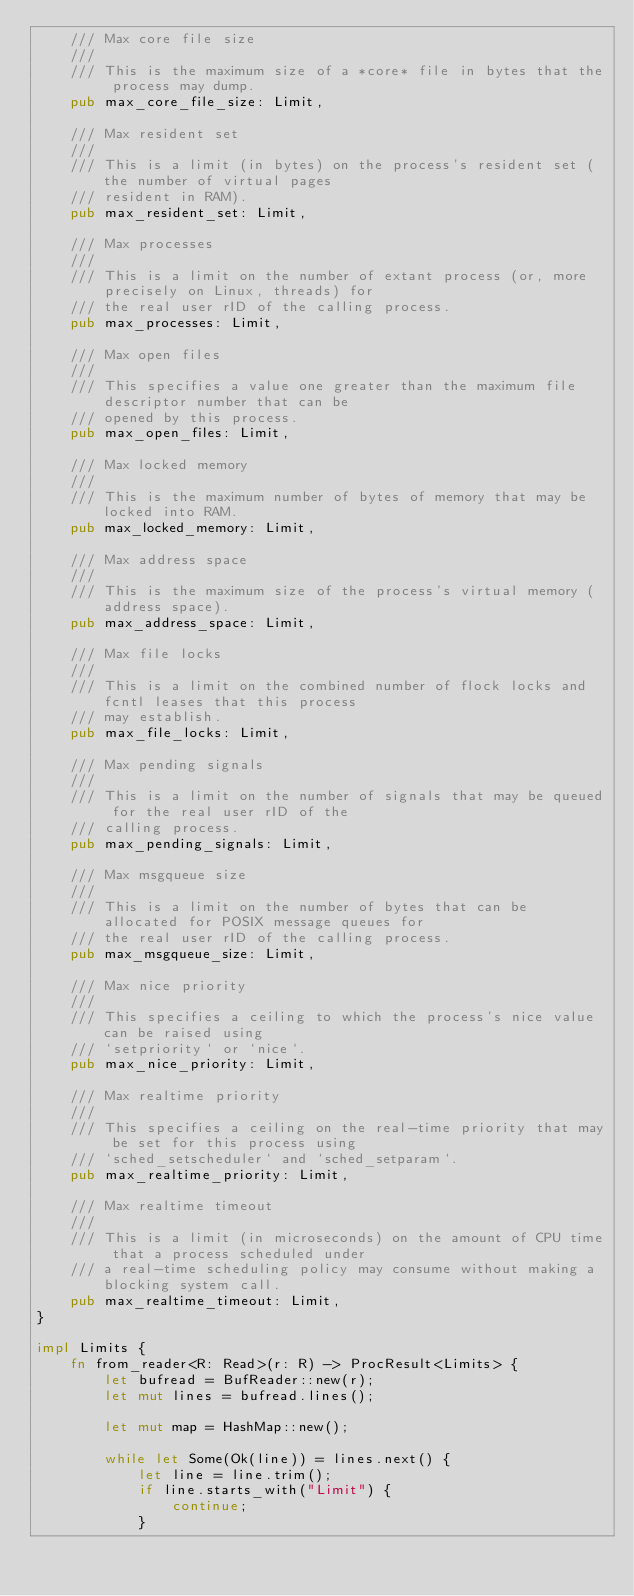Convert code to text. <code><loc_0><loc_0><loc_500><loc_500><_Rust_>    /// Max core file size
    ///
    /// This is the maximum size of a *core* file in bytes that the process may dump.
    pub max_core_file_size: Limit,

    /// Max resident set
    ///
    /// This is a limit (in bytes) on the process's resident set (the number of virtual pages
    /// resident in RAM).
    pub max_resident_set: Limit,

    /// Max processes
    ///
    /// This is a limit on the number of extant process (or, more precisely on Linux, threads) for
    /// the real user rID of the calling process.
    pub max_processes: Limit,

    /// Max open files
    ///
    /// This specifies a value one greater than the maximum file descriptor number that can be
    /// opened by this process.
    pub max_open_files: Limit,

    /// Max locked memory
    ///
    /// This is the maximum number of bytes of memory that may be locked into RAM.
    pub max_locked_memory: Limit,

    /// Max address space
    ///
    /// This is the maximum size of the process's virtual memory (address space).
    pub max_address_space: Limit,

    /// Max file locks
    ///
    /// This is a limit on the combined number of flock locks and fcntl leases that this process
    /// may establish.
    pub max_file_locks: Limit,

    /// Max pending signals
    ///
    /// This is a limit on the number of signals that may be queued for the real user rID of the
    /// calling process.
    pub max_pending_signals: Limit,

    /// Max msgqueue size
    ///
    /// This is a limit on the number of bytes that can be allocated for POSIX message queues for
    /// the real user rID of the calling process.
    pub max_msgqueue_size: Limit,

    /// Max nice priority
    ///
    /// This specifies a ceiling to which the process's nice value can be raised using
    /// `setpriority` or `nice`.
    pub max_nice_priority: Limit,

    /// Max realtime priority
    ///
    /// This specifies a ceiling on the real-time priority that may be set for this process using
    /// `sched_setscheduler` and `sched_setparam`.
    pub max_realtime_priority: Limit,

    /// Max realtime timeout
    ///
    /// This is a limit (in microseconds) on the amount of CPU time that a process scheduled under
    /// a real-time scheduling policy may consume without making a blocking system call.
    pub max_realtime_timeout: Limit,
}

impl Limits {
    fn from_reader<R: Read>(r: R) -> ProcResult<Limits> {
        let bufread = BufReader::new(r);
        let mut lines = bufread.lines();

        let mut map = HashMap::new();

        while let Some(Ok(line)) = lines.next() {
            let line = line.trim();
            if line.starts_with("Limit") {
                continue;
            }</code> 